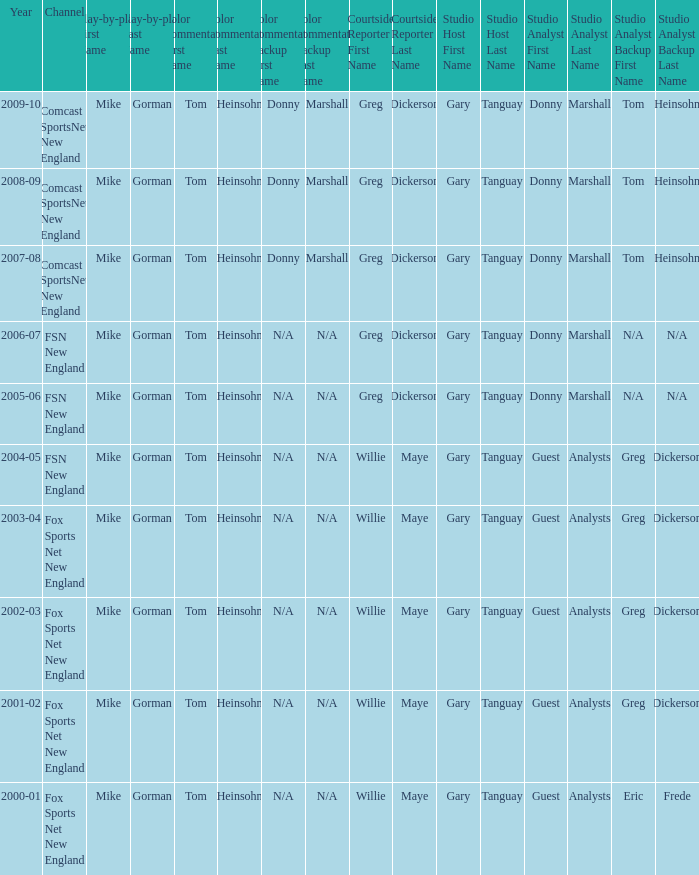WHich Color commentatorhas a Studio host of gary tanguay & eric frede? Tom Heinsohn. 